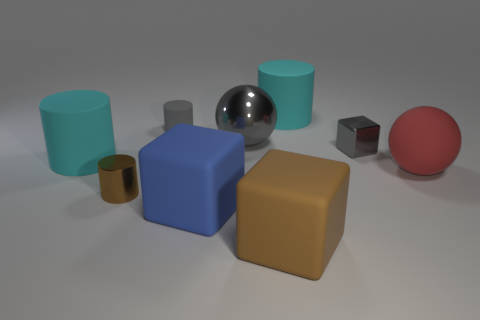Subtract all red balls. Subtract all brown cylinders. How many balls are left? 1 Add 1 tiny gray metal blocks. How many objects exist? 10 Subtract all balls. How many objects are left? 7 Add 7 large balls. How many large balls are left? 9 Add 9 blue rubber objects. How many blue rubber objects exist? 10 Subtract 0 red cylinders. How many objects are left? 9 Subtract all cyan cylinders. Subtract all tiny gray things. How many objects are left? 5 